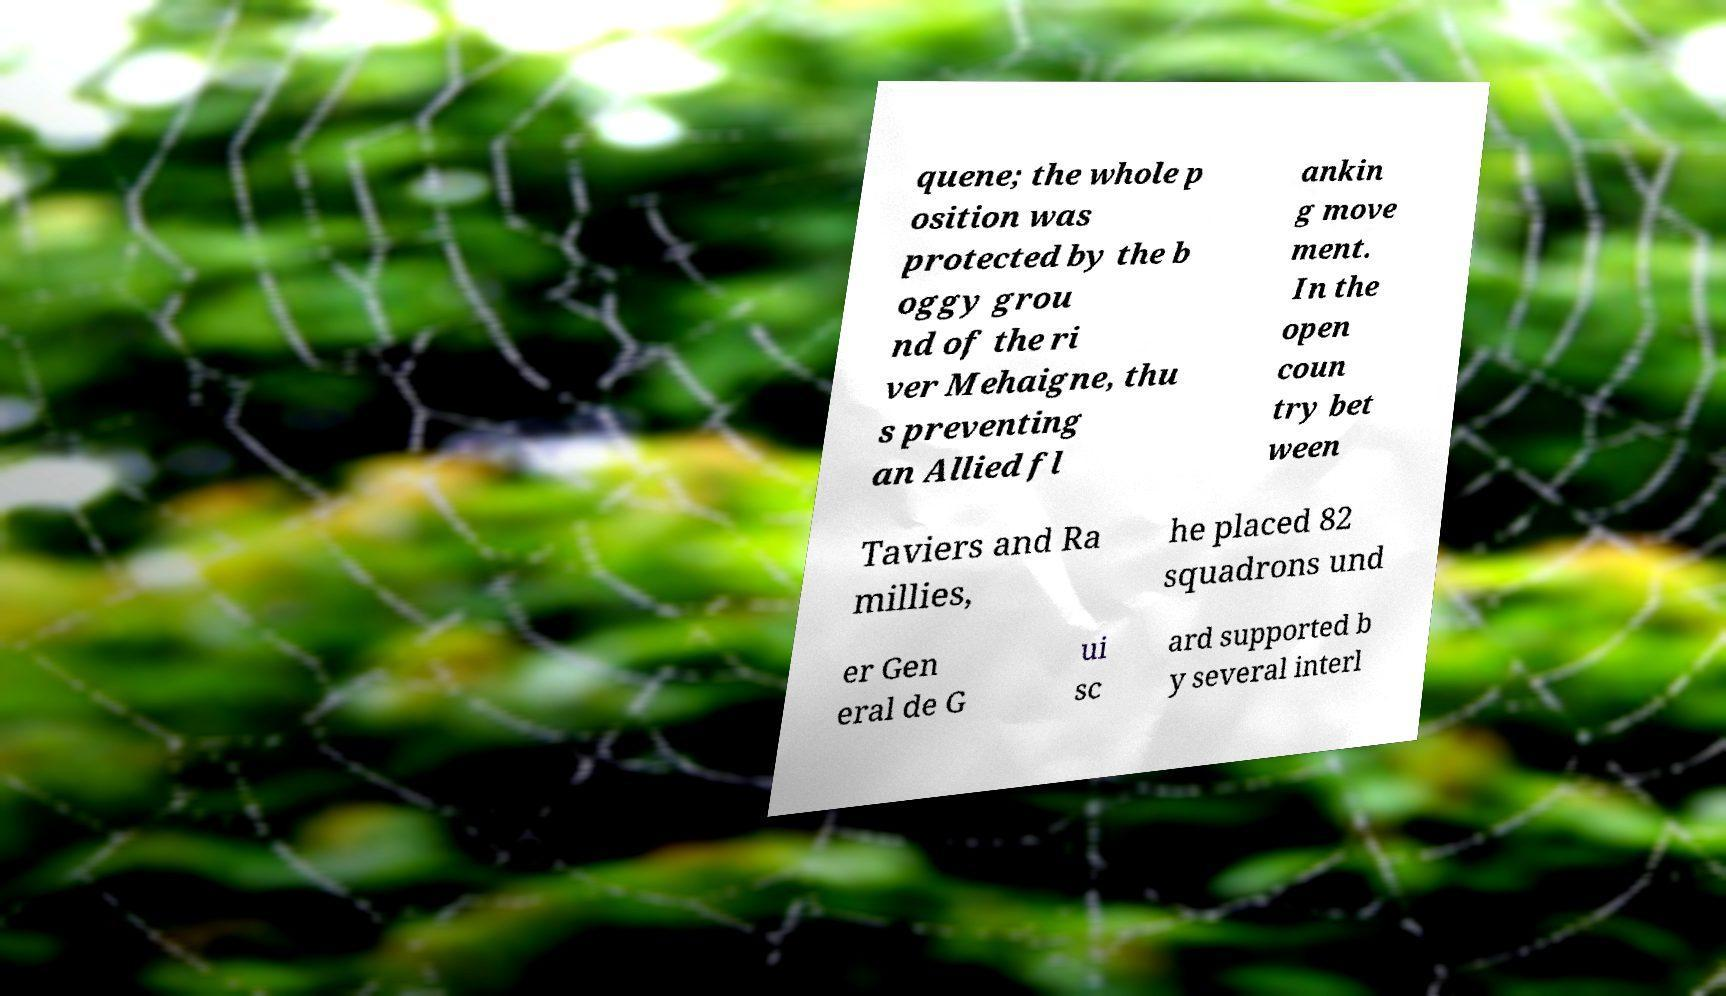What messages or text are displayed in this image? I need them in a readable, typed format. quene; the whole p osition was protected by the b oggy grou nd of the ri ver Mehaigne, thu s preventing an Allied fl ankin g move ment. In the open coun try bet ween Taviers and Ra millies, he placed 82 squadrons und er Gen eral de G ui sc ard supported b y several interl 